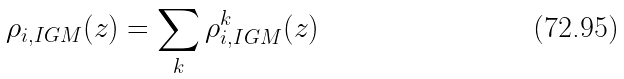Convert formula to latex. <formula><loc_0><loc_0><loc_500><loc_500>\rho _ { i , I G M } ( z ) = \sum _ { k } \rho _ { i , I G M } ^ { k } ( z )</formula> 